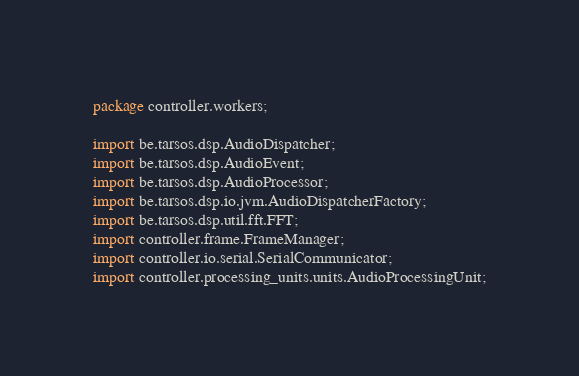Convert code to text. <code><loc_0><loc_0><loc_500><loc_500><_Java_>package controller.workers;

import be.tarsos.dsp.AudioDispatcher;
import be.tarsos.dsp.AudioEvent;
import be.tarsos.dsp.AudioProcessor;
import be.tarsos.dsp.io.jvm.AudioDispatcherFactory;
import be.tarsos.dsp.util.fft.FFT;
import controller.frame.FrameManager;
import controller.io.serial.SerialCommunicator;
import controller.processing_units.units.AudioProcessingUnit;</code> 